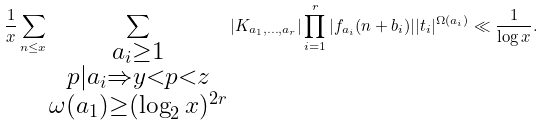<formula> <loc_0><loc_0><loc_500><loc_500>\frac { 1 } { x } \sum _ { n \leq x } \sum _ { \substack { a _ { i } \geq 1 \\ p | a _ { i } \Rightarrow y < p < z \\ \omega ( a _ { 1 } ) \geq ( \log _ { 2 } x ) ^ { 2 r } } } | K _ { a _ { 1 } , \dots , a _ { r } } | \prod _ { i = 1 } ^ { r } | f _ { a _ { i } } ( n + b _ { i } ) | | t _ { i } | ^ { \Omega ( a _ { i } ) } \ll \frac { 1 } { \log x } .</formula> 